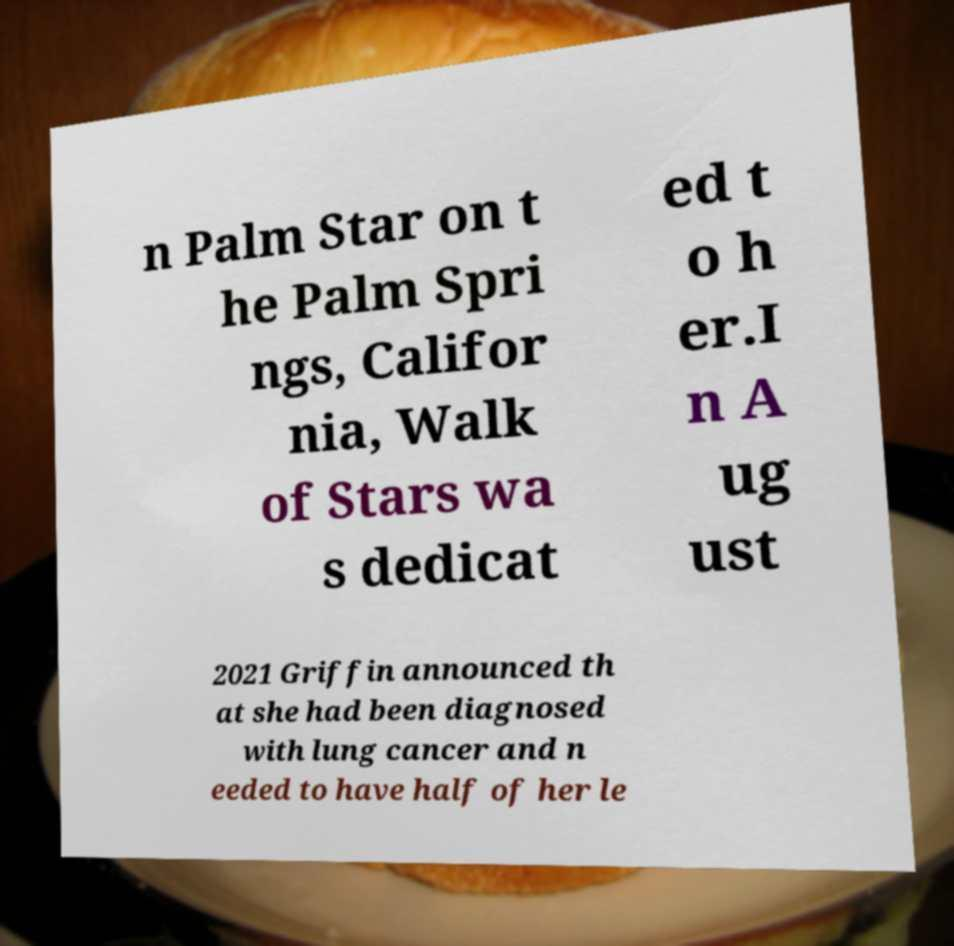Can you accurately transcribe the text from the provided image for me? n Palm Star on t he Palm Spri ngs, Califor nia, Walk of Stars wa s dedicat ed t o h er.I n A ug ust 2021 Griffin announced th at she had been diagnosed with lung cancer and n eeded to have half of her le 